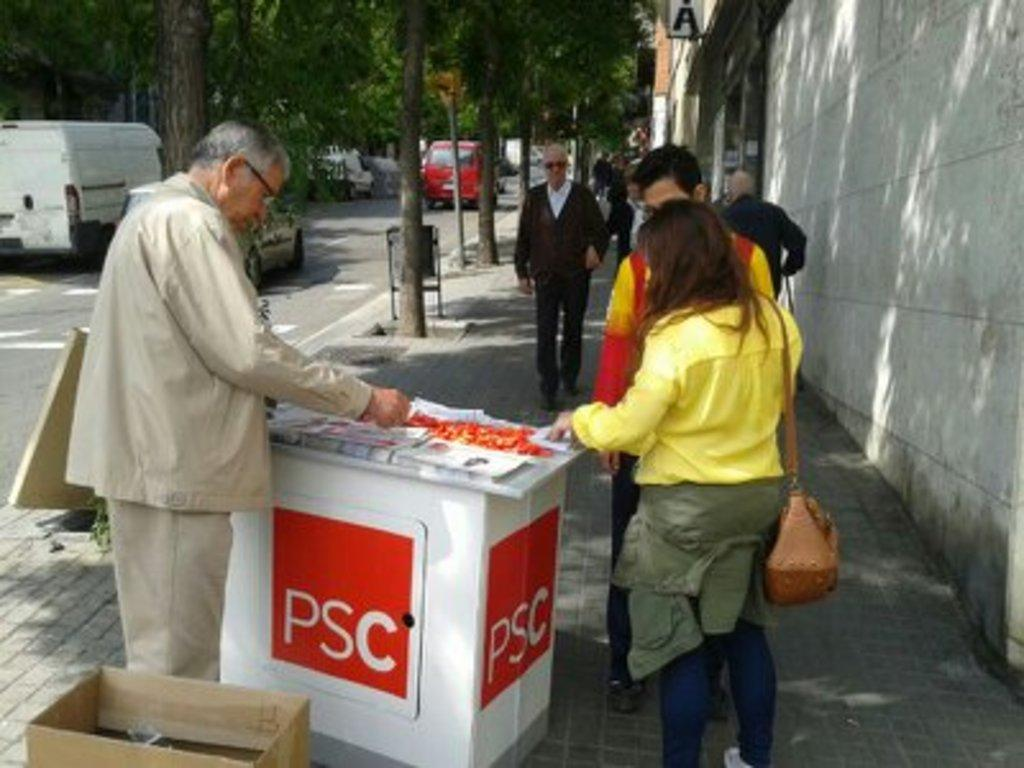Who or what can be seen in the image? There are people in the image. What object is present in the image that could be used for storage or transportation? There is a box in the image. What item in the image might be used for displaying photos or artwork? There is a photo frame in the image. What type of transportation is visible in the image? There are vehicles in the image. What type of natural vegetation can be seen in the image? There are trees in the image. What type of toys can be seen playing with the vehicles in the image? There are no toys present in the image; it only features people, a box, a photo frame, vehicles, and trees. 